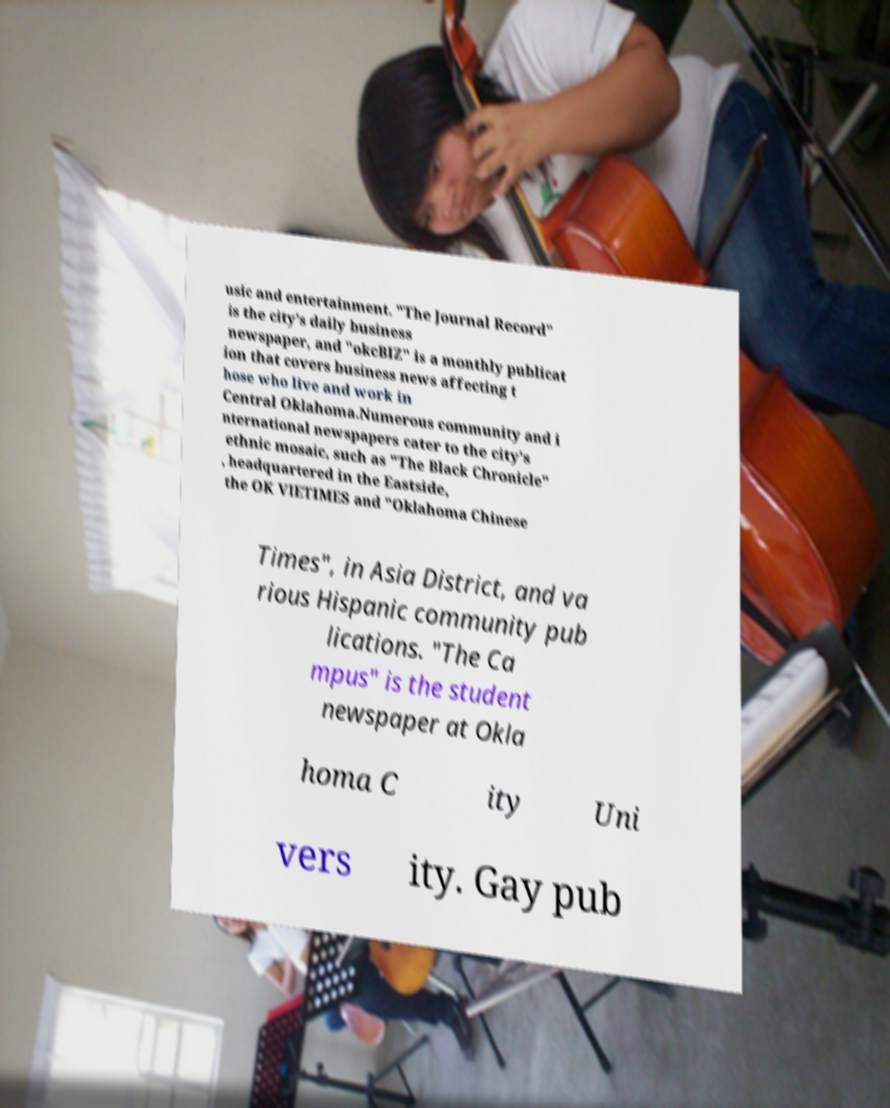There's text embedded in this image that I need extracted. Can you transcribe it verbatim? usic and entertainment. "The Journal Record" is the city's daily business newspaper, and "okcBIZ" is a monthly publicat ion that covers business news affecting t hose who live and work in Central Oklahoma.Numerous community and i nternational newspapers cater to the city's ethnic mosaic, such as "The Black Chronicle" , headquartered in the Eastside, the OK VIETIMES and "Oklahoma Chinese Times", in Asia District, and va rious Hispanic community pub lications. "The Ca mpus" is the student newspaper at Okla homa C ity Uni vers ity. Gay pub 